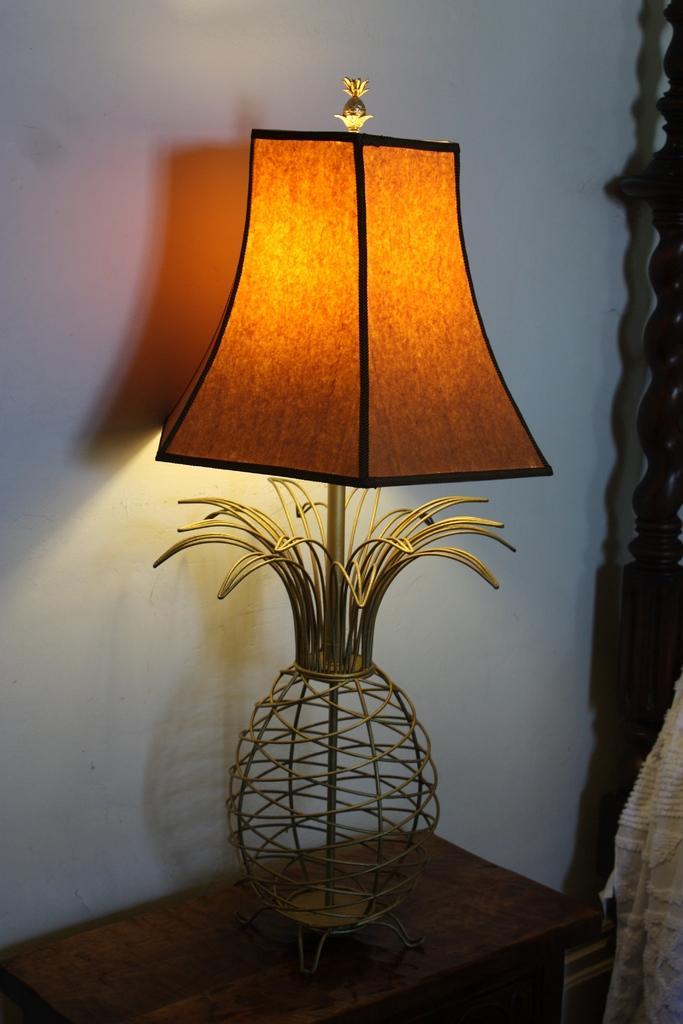Please provide a concise description of this image. In the foreground of this image, there is a lamp on a table. On right there is a cloth and coat. In the background there is a wall. 